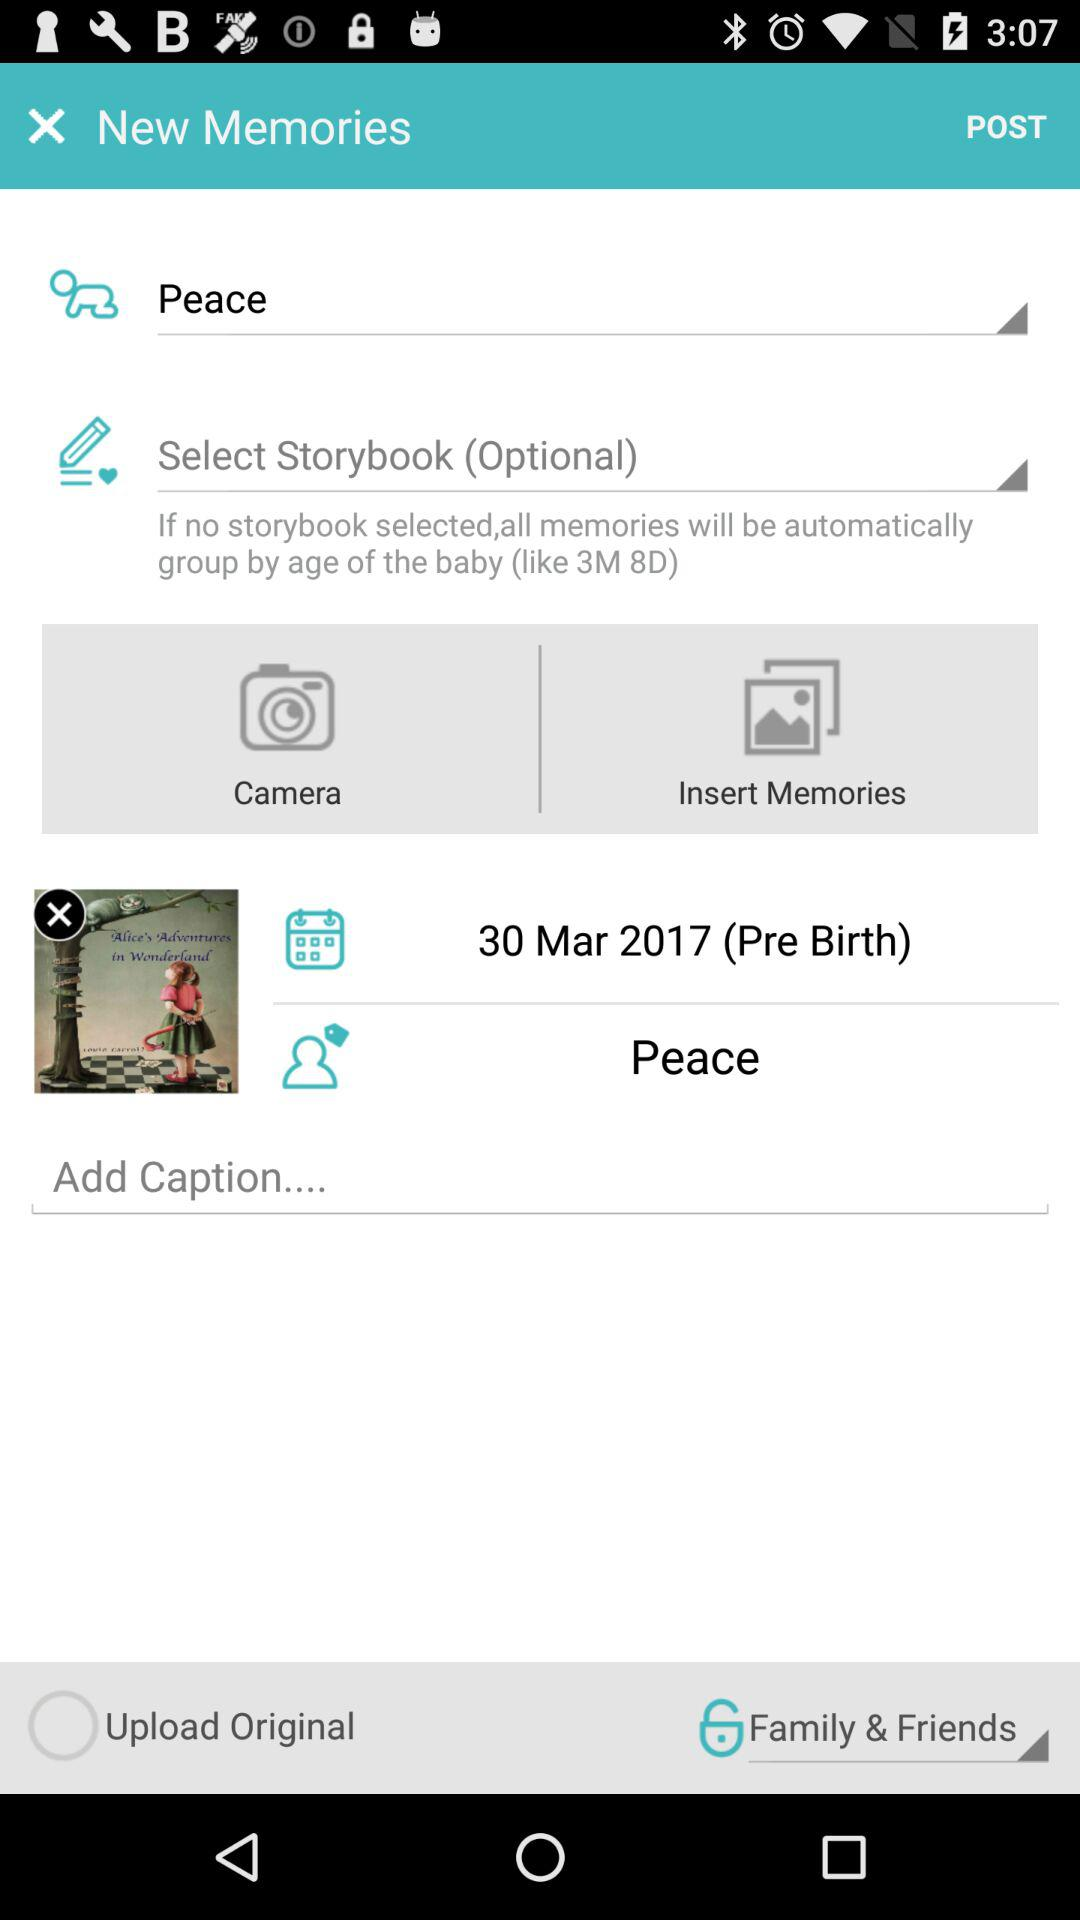What is the status of "Upload Original"? The status is "off". 